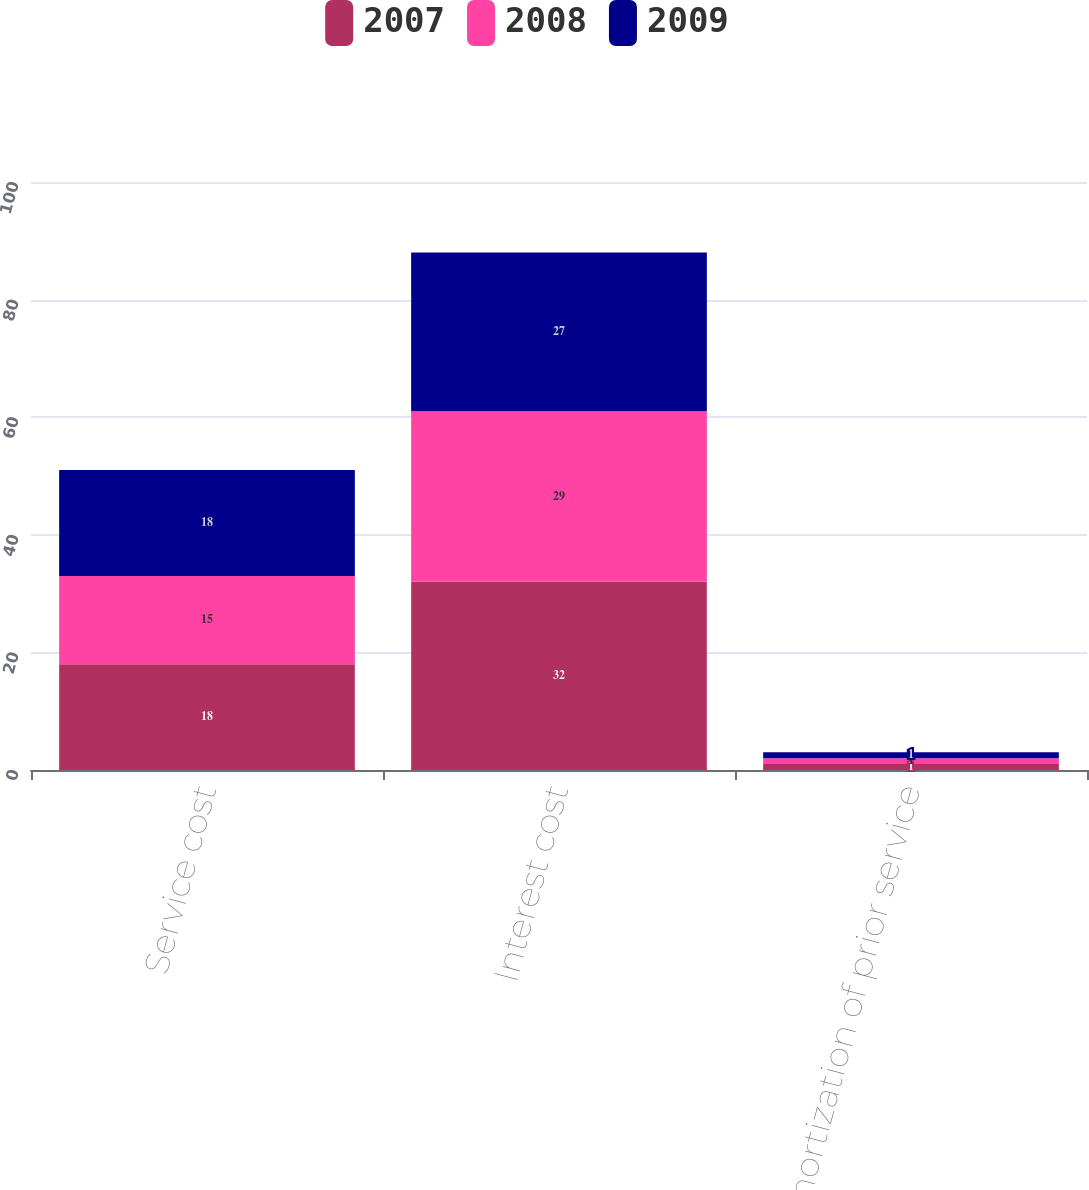<chart> <loc_0><loc_0><loc_500><loc_500><stacked_bar_chart><ecel><fcel>Service cost<fcel>Interest cost<fcel>Amortization of prior service<nl><fcel>2007<fcel>18<fcel>32<fcel>1<nl><fcel>2008<fcel>15<fcel>29<fcel>1<nl><fcel>2009<fcel>18<fcel>27<fcel>1<nl></chart> 